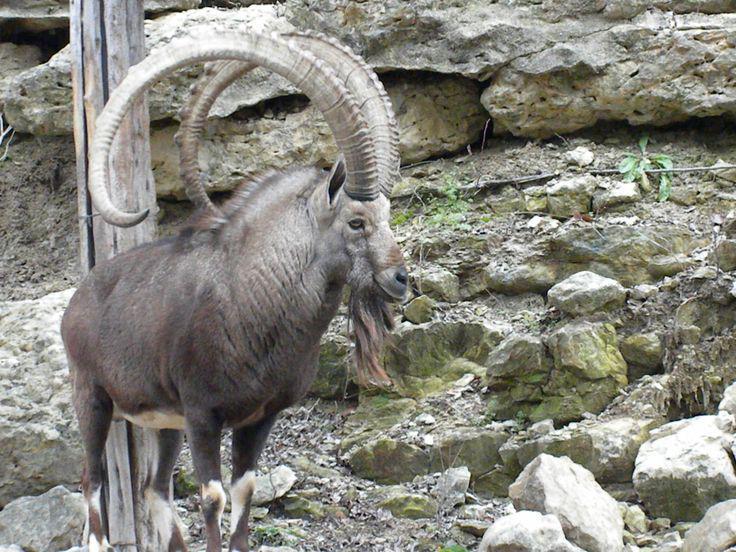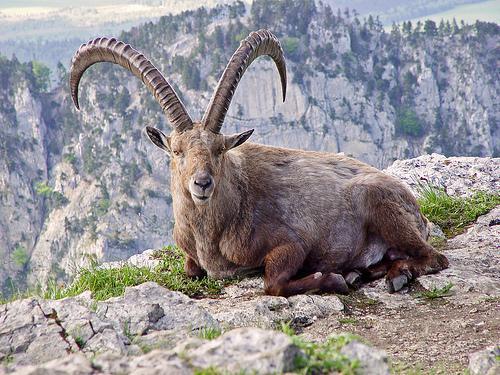The first image is the image on the left, the second image is the image on the right. Examine the images to the left and right. Is the description "the animal on the right image is facing left" accurate? Answer yes or no. Yes. 